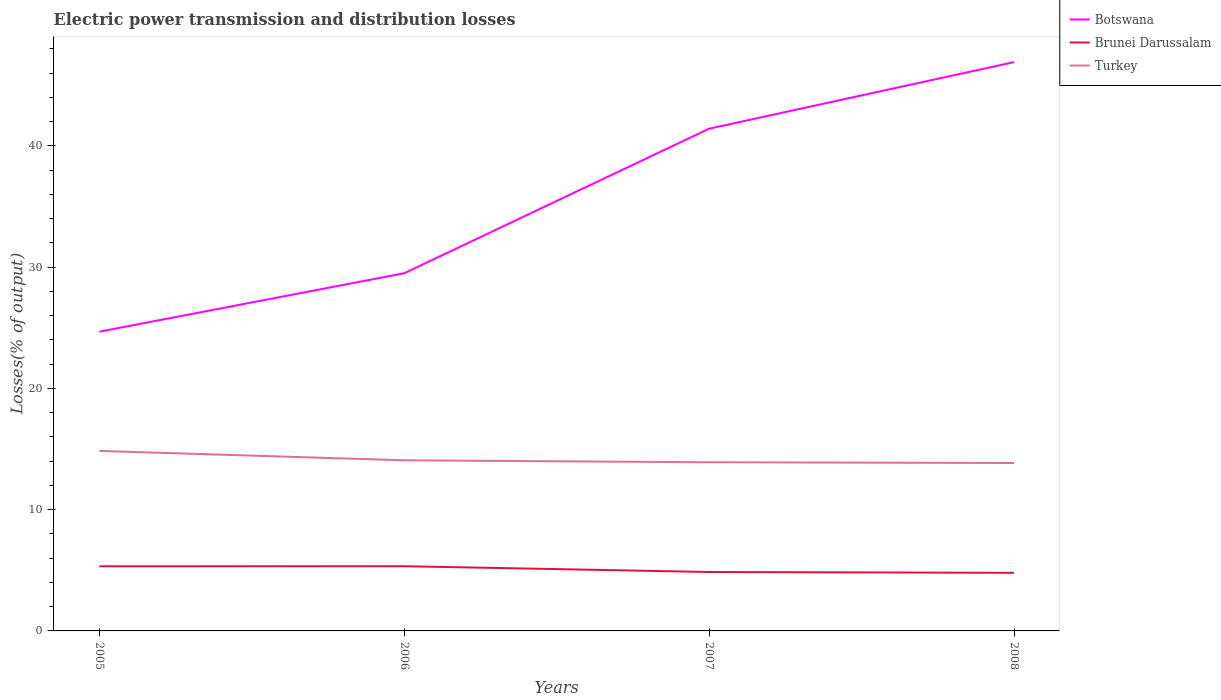Is the number of lines equal to the number of legend labels?
Offer a terse response. Yes. Across all years, what is the maximum electric power transmission and distribution losses in Turkey?
Provide a succinct answer. 13.85. In which year was the electric power transmission and distribution losses in Turkey maximum?
Provide a succinct answer. 2008. What is the total electric power transmission and distribution losses in Botswana in the graph?
Make the answer very short. -4.82. What is the difference between the highest and the second highest electric power transmission and distribution losses in Brunei Darussalam?
Offer a terse response. 0.55. What is the difference between the highest and the lowest electric power transmission and distribution losses in Turkey?
Give a very brief answer. 1. Is the electric power transmission and distribution losses in Brunei Darussalam strictly greater than the electric power transmission and distribution losses in Turkey over the years?
Offer a terse response. Yes. How many lines are there?
Ensure brevity in your answer.  3. How many years are there in the graph?
Offer a terse response. 4. What is the difference between two consecutive major ticks on the Y-axis?
Your response must be concise. 10. Does the graph contain any zero values?
Keep it short and to the point. No. How are the legend labels stacked?
Ensure brevity in your answer.  Vertical. What is the title of the graph?
Provide a succinct answer. Electric power transmission and distribution losses. What is the label or title of the X-axis?
Your response must be concise. Years. What is the label or title of the Y-axis?
Give a very brief answer. Losses(% of output). What is the Losses(% of output) of Botswana in 2005?
Give a very brief answer. 24.68. What is the Losses(% of output) of Brunei Darussalam in 2005?
Provide a short and direct response. 5.33. What is the Losses(% of output) in Turkey in 2005?
Keep it short and to the point. 14.85. What is the Losses(% of output) of Botswana in 2006?
Your response must be concise. 29.5. What is the Losses(% of output) of Brunei Darussalam in 2006?
Offer a terse response. 5.34. What is the Losses(% of output) in Turkey in 2006?
Provide a succinct answer. 14.07. What is the Losses(% of output) of Botswana in 2007?
Make the answer very short. 41.43. What is the Losses(% of output) of Brunei Darussalam in 2007?
Give a very brief answer. 4.86. What is the Losses(% of output) in Turkey in 2007?
Offer a terse response. 13.91. What is the Losses(% of output) in Botswana in 2008?
Keep it short and to the point. 46.92. What is the Losses(% of output) in Brunei Darussalam in 2008?
Your response must be concise. 4.79. What is the Losses(% of output) in Turkey in 2008?
Your answer should be compact. 13.85. Across all years, what is the maximum Losses(% of output) in Botswana?
Give a very brief answer. 46.92. Across all years, what is the maximum Losses(% of output) of Brunei Darussalam?
Keep it short and to the point. 5.34. Across all years, what is the maximum Losses(% of output) in Turkey?
Provide a succinct answer. 14.85. Across all years, what is the minimum Losses(% of output) of Botswana?
Your answer should be very brief. 24.68. Across all years, what is the minimum Losses(% of output) in Brunei Darussalam?
Offer a very short reply. 4.79. Across all years, what is the minimum Losses(% of output) of Turkey?
Offer a terse response. 13.85. What is the total Losses(% of output) of Botswana in the graph?
Offer a very short reply. 142.52. What is the total Losses(% of output) of Brunei Darussalam in the graph?
Give a very brief answer. 20.32. What is the total Losses(% of output) of Turkey in the graph?
Offer a very short reply. 56.68. What is the difference between the Losses(% of output) in Botswana in 2005 and that in 2006?
Make the answer very short. -4.82. What is the difference between the Losses(% of output) in Brunei Darussalam in 2005 and that in 2006?
Offer a very short reply. -0.01. What is the difference between the Losses(% of output) of Turkey in 2005 and that in 2006?
Your answer should be very brief. 0.77. What is the difference between the Losses(% of output) in Botswana in 2005 and that in 2007?
Your response must be concise. -16.74. What is the difference between the Losses(% of output) of Brunei Darussalam in 2005 and that in 2007?
Ensure brevity in your answer.  0.47. What is the difference between the Losses(% of output) in Turkey in 2005 and that in 2007?
Your answer should be very brief. 0.94. What is the difference between the Losses(% of output) of Botswana in 2005 and that in 2008?
Provide a short and direct response. -22.23. What is the difference between the Losses(% of output) of Brunei Darussalam in 2005 and that in 2008?
Your answer should be very brief. 0.54. What is the difference between the Losses(% of output) in Botswana in 2006 and that in 2007?
Offer a terse response. -11.92. What is the difference between the Losses(% of output) in Brunei Darussalam in 2006 and that in 2007?
Ensure brevity in your answer.  0.48. What is the difference between the Losses(% of output) in Turkey in 2006 and that in 2007?
Provide a short and direct response. 0.16. What is the difference between the Losses(% of output) in Botswana in 2006 and that in 2008?
Keep it short and to the point. -17.41. What is the difference between the Losses(% of output) of Brunei Darussalam in 2006 and that in 2008?
Your answer should be very brief. 0.55. What is the difference between the Losses(% of output) of Turkey in 2006 and that in 2008?
Ensure brevity in your answer.  0.22. What is the difference between the Losses(% of output) of Botswana in 2007 and that in 2008?
Your answer should be very brief. -5.49. What is the difference between the Losses(% of output) in Brunei Darussalam in 2007 and that in 2008?
Offer a very short reply. 0.07. What is the difference between the Losses(% of output) in Turkey in 2007 and that in 2008?
Offer a very short reply. 0.06. What is the difference between the Losses(% of output) in Botswana in 2005 and the Losses(% of output) in Brunei Darussalam in 2006?
Offer a very short reply. 19.35. What is the difference between the Losses(% of output) of Botswana in 2005 and the Losses(% of output) of Turkey in 2006?
Your answer should be compact. 10.61. What is the difference between the Losses(% of output) in Brunei Darussalam in 2005 and the Losses(% of output) in Turkey in 2006?
Offer a very short reply. -8.74. What is the difference between the Losses(% of output) of Botswana in 2005 and the Losses(% of output) of Brunei Darussalam in 2007?
Your answer should be compact. 19.82. What is the difference between the Losses(% of output) in Botswana in 2005 and the Losses(% of output) in Turkey in 2007?
Your response must be concise. 10.77. What is the difference between the Losses(% of output) of Brunei Darussalam in 2005 and the Losses(% of output) of Turkey in 2007?
Your answer should be compact. -8.58. What is the difference between the Losses(% of output) of Botswana in 2005 and the Losses(% of output) of Brunei Darussalam in 2008?
Provide a short and direct response. 19.89. What is the difference between the Losses(% of output) in Botswana in 2005 and the Losses(% of output) in Turkey in 2008?
Offer a very short reply. 10.83. What is the difference between the Losses(% of output) in Brunei Darussalam in 2005 and the Losses(% of output) in Turkey in 2008?
Provide a short and direct response. -8.52. What is the difference between the Losses(% of output) of Botswana in 2006 and the Losses(% of output) of Brunei Darussalam in 2007?
Your answer should be very brief. 24.64. What is the difference between the Losses(% of output) in Botswana in 2006 and the Losses(% of output) in Turkey in 2007?
Provide a succinct answer. 15.59. What is the difference between the Losses(% of output) in Brunei Darussalam in 2006 and the Losses(% of output) in Turkey in 2007?
Ensure brevity in your answer.  -8.57. What is the difference between the Losses(% of output) in Botswana in 2006 and the Losses(% of output) in Brunei Darussalam in 2008?
Your response must be concise. 24.71. What is the difference between the Losses(% of output) in Botswana in 2006 and the Losses(% of output) in Turkey in 2008?
Make the answer very short. 15.65. What is the difference between the Losses(% of output) of Brunei Darussalam in 2006 and the Losses(% of output) of Turkey in 2008?
Keep it short and to the point. -8.51. What is the difference between the Losses(% of output) in Botswana in 2007 and the Losses(% of output) in Brunei Darussalam in 2008?
Keep it short and to the point. 36.63. What is the difference between the Losses(% of output) of Botswana in 2007 and the Losses(% of output) of Turkey in 2008?
Offer a terse response. 27.58. What is the difference between the Losses(% of output) in Brunei Darussalam in 2007 and the Losses(% of output) in Turkey in 2008?
Give a very brief answer. -8.99. What is the average Losses(% of output) in Botswana per year?
Your response must be concise. 35.63. What is the average Losses(% of output) in Brunei Darussalam per year?
Offer a terse response. 5.08. What is the average Losses(% of output) of Turkey per year?
Ensure brevity in your answer.  14.17. In the year 2005, what is the difference between the Losses(% of output) of Botswana and Losses(% of output) of Brunei Darussalam?
Give a very brief answer. 19.35. In the year 2005, what is the difference between the Losses(% of output) of Botswana and Losses(% of output) of Turkey?
Provide a succinct answer. 9.84. In the year 2005, what is the difference between the Losses(% of output) of Brunei Darussalam and Losses(% of output) of Turkey?
Provide a short and direct response. -9.52. In the year 2006, what is the difference between the Losses(% of output) of Botswana and Losses(% of output) of Brunei Darussalam?
Keep it short and to the point. 24.16. In the year 2006, what is the difference between the Losses(% of output) in Botswana and Losses(% of output) in Turkey?
Your response must be concise. 15.43. In the year 2006, what is the difference between the Losses(% of output) in Brunei Darussalam and Losses(% of output) in Turkey?
Provide a short and direct response. -8.74. In the year 2007, what is the difference between the Losses(% of output) of Botswana and Losses(% of output) of Brunei Darussalam?
Offer a very short reply. 36.56. In the year 2007, what is the difference between the Losses(% of output) in Botswana and Losses(% of output) in Turkey?
Make the answer very short. 27.51. In the year 2007, what is the difference between the Losses(% of output) in Brunei Darussalam and Losses(% of output) in Turkey?
Provide a succinct answer. -9.05. In the year 2008, what is the difference between the Losses(% of output) of Botswana and Losses(% of output) of Brunei Darussalam?
Give a very brief answer. 42.12. In the year 2008, what is the difference between the Losses(% of output) of Botswana and Losses(% of output) of Turkey?
Provide a succinct answer. 33.07. In the year 2008, what is the difference between the Losses(% of output) in Brunei Darussalam and Losses(% of output) in Turkey?
Ensure brevity in your answer.  -9.06. What is the ratio of the Losses(% of output) in Botswana in 2005 to that in 2006?
Your response must be concise. 0.84. What is the ratio of the Losses(% of output) in Brunei Darussalam in 2005 to that in 2006?
Give a very brief answer. 1. What is the ratio of the Losses(% of output) of Turkey in 2005 to that in 2006?
Offer a very short reply. 1.05. What is the ratio of the Losses(% of output) in Botswana in 2005 to that in 2007?
Provide a succinct answer. 0.6. What is the ratio of the Losses(% of output) in Brunei Darussalam in 2005 to that in 2007?
Your answer should be compact. 1.1. What is the ratio of the Losses(% of output) in Turkey in 2005 to that in 2007?
Provide a short and direct response. 1.07. What is the ratio of the Losses(% of output) in Botswana in 2005 to that in 2008?
Ensure brevity in your answer.  0.53. What is the ratio of the Losses(% of output) in Brunei Darussalam in 2005 to that in 2008?
Ensure brevity in your answer.  1.11. What is the ratio of the Losses(% of output) in Turkey in 2005 to that in 2008?
Your answer should be very brief. 1.07. What is the ratio of the Losses(% of output) of Botswana in 2006 to that in 2007?
Offer a terse response. 0.71. What is the ratio of the Losses(% of output) of Brunei Darussalam in 2006 to that in 2007?
Make the answer very short. 1.1. What is the ratio of the Losses(% of output) in Turkey in 2006 to that in 2007?
Your answer should be very brief. 1.01. What is the ratio of the Losses(% of output) in Botswana in 2006 to that in 2008?
Your answer should be very brief. 0.63. What is the ratio of the Losses(% of output) in Brunei Darussalam in 2006 to that in 2008?
Provide a succinct answer. 1.11. What is the ratio of the Losses(% of output) in Turkey in 2006 to that in 2008?
Provide a short and direct response. 1.02. What is the ratio of the Losses(% of output) of Botswana in 2007 to that in 2008?
Provide a succinct answer. 0.88. What is the ratio of the Losses(% of output) of Brunei Darussalam in 2007 to that in 2008?
Your response must be concise. 1.01. What is the difference between the highest and the second highest Losses(% of output) in Botswana?
Provide a short and direct response. 5.49. What is the difference between the highest and the second highest Losses(% of output) in Brunei Darussalam?
Offer a very short reply. 0.01. What is the difference between the highest and the second highest Losses(% of output) in Turkey?
Your answer should be very brief. 0.77. What is the difference between the highest and the lowest Losses(% of output) of Botswana?
Offer a very short reply. 22.23. What is the difference between the highest and the lowest Losses(% of output) in Brunei Darussalam?
Give a very brief answer. 0.55. 